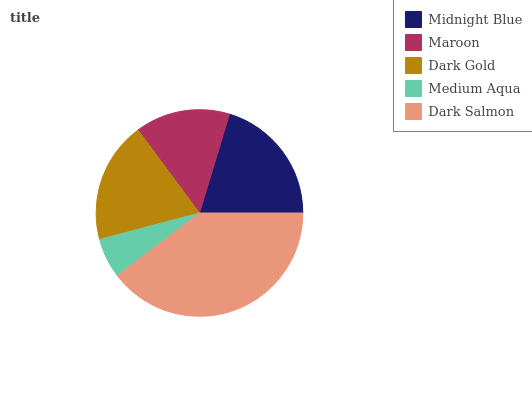Is Medium Aqua the minimum?
Answer yes or no. Yes. Is Dark Salmon the maximum?
Answer yes or no. Yes. Is Maroon the minimum?
Answer yes or no. No. Is Maroon the maximum?
Answer yes or no. No. Is Midnight Blue greater than Maroon?
Answer yes or no. Yes. Is Maroon less than Midnight Blue?
Answer yes or no. Yes. Is Maroon greater than Midnight Blue?
Answer yes or no. No. Is Midnight Blue less than Maroon?
Answer yes or no. No. Is Dark Gold the high median?
Answer yes or no. Yes. Is Dark Gold the low median?
Answer yes or no. Yes. Is Medium Aqua the high median?
Answer yes or no. No. Is Maroon the low median?
Answer yes or no. No. 